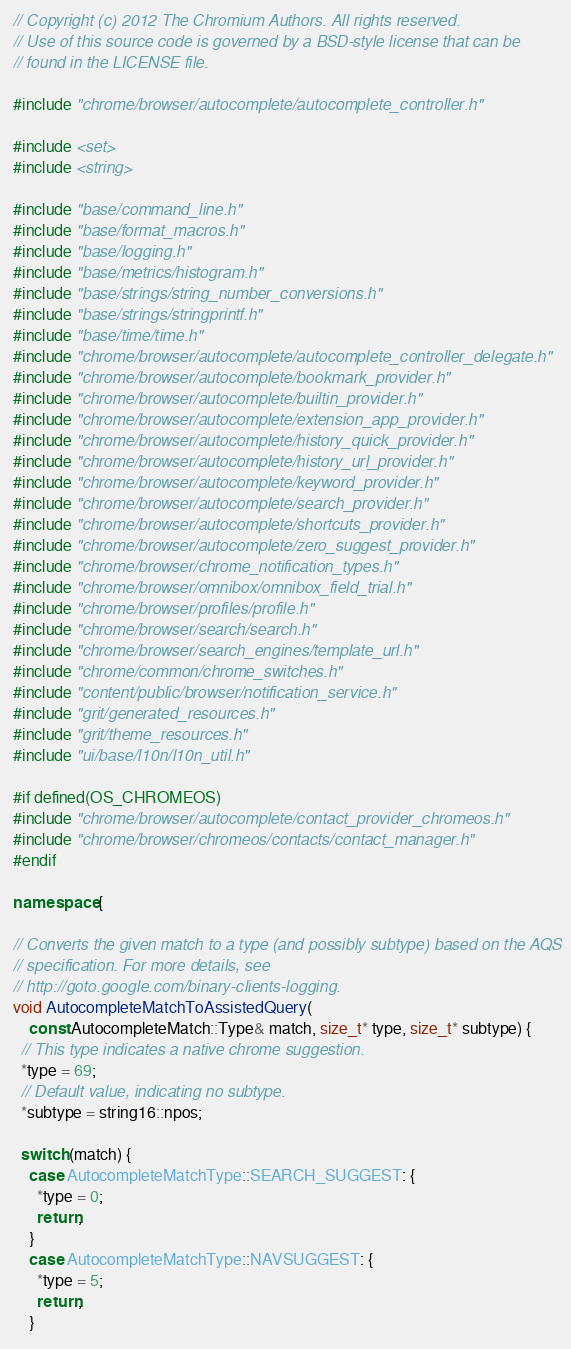Convert code to text. <code><loc_0><loc_0><loc_500><loc_500><_C++_>// Copyright (c) 2012 The Chromium Authors. All rights reserved.
// Use of this source code is governed by a BSD-style license that can be
// found in the LICENSE file.

#include "chrome/browser/autocomplete/autocomplete_controller.h"

#include <set>
#include <string>

#include "base/command_line.h"
#include "base/format_macros.h"
#include "base/logging.h"
#include "base/metrics/histogram.h"
#include "base/strings/string_number_conversions.h"
#include "base/strings/stringprintf.h"
#include "base/time/time.h"
#include "chrome/browser/autocomplete/autocomplete_controller_delegate.h"
#include "chrome/browser/autocomplete/bookmark_provider.h"
#include "chrome/browser/autocomplete/builtin_provider.h"
#include "chrome/browser/autocomplete/extension_app_provider.h"
#include "chrome/browser/autocomplete/history_quick_provider.h"
#include "chrome/browser/autocomplete/history_url_provider.h"
#include "chrome/browser/autocomplete/keyword_provider.h"
#include "chrome/browser/autocomplete/search_provider.h"
#include "chrome/browser/autocomplete/shortcuts_provider.h"
#include "chrome/browser/autocomplete/zero_suggest_provider.h"
#include "chrome/browser/chrome_notification_types.h"
#include "chrome/browser/omnibox/omnibox_field_trial.h"
#include "chrome/browser/profiles/profile.h"
#include "chrome/browser/search/search.h"
#include "chrome/browser/search_engines/template_url.h"
#include "chrome/common/chrome_switches.h"
#include "content/public/browser/notification_service.h"
#include "grit/generated_resources.h"
#include "grit/theme_resources.h"
#include "ui/base/l10n/l10n_util.h"

#if defined(OS_CHROMEOS)
#include "chrome/browser/autocomplete/contact_provider_chromeos.h"
#include "chrome/browser/chromeos/contacts/contact_manager.h"
#endif

namespace {

// Converts the given match to a type (and possibly subtype) based on the AQS
// specification. For more details, see
// http://goto.google.com/binary-clients-logging.
void AutocompleteMatchToAssistedQuery(
    const AutocompleteMatch::Type& match, size_t* type, size_t* subtype) {
  // This type indicates a native chrome suggestion.
  *type = 69;
  // Default value, indicating no subtype.
  *subtype = string16::npos;

  switch (match) {
    case AutocompleteMatchType::SEARCH_SUGGEST: {
      *type = 0;
      return;
    }
    case AutocompleteMatchType::NAVSUGGEST: {
      *type = 5;
      return;
    }</code> 